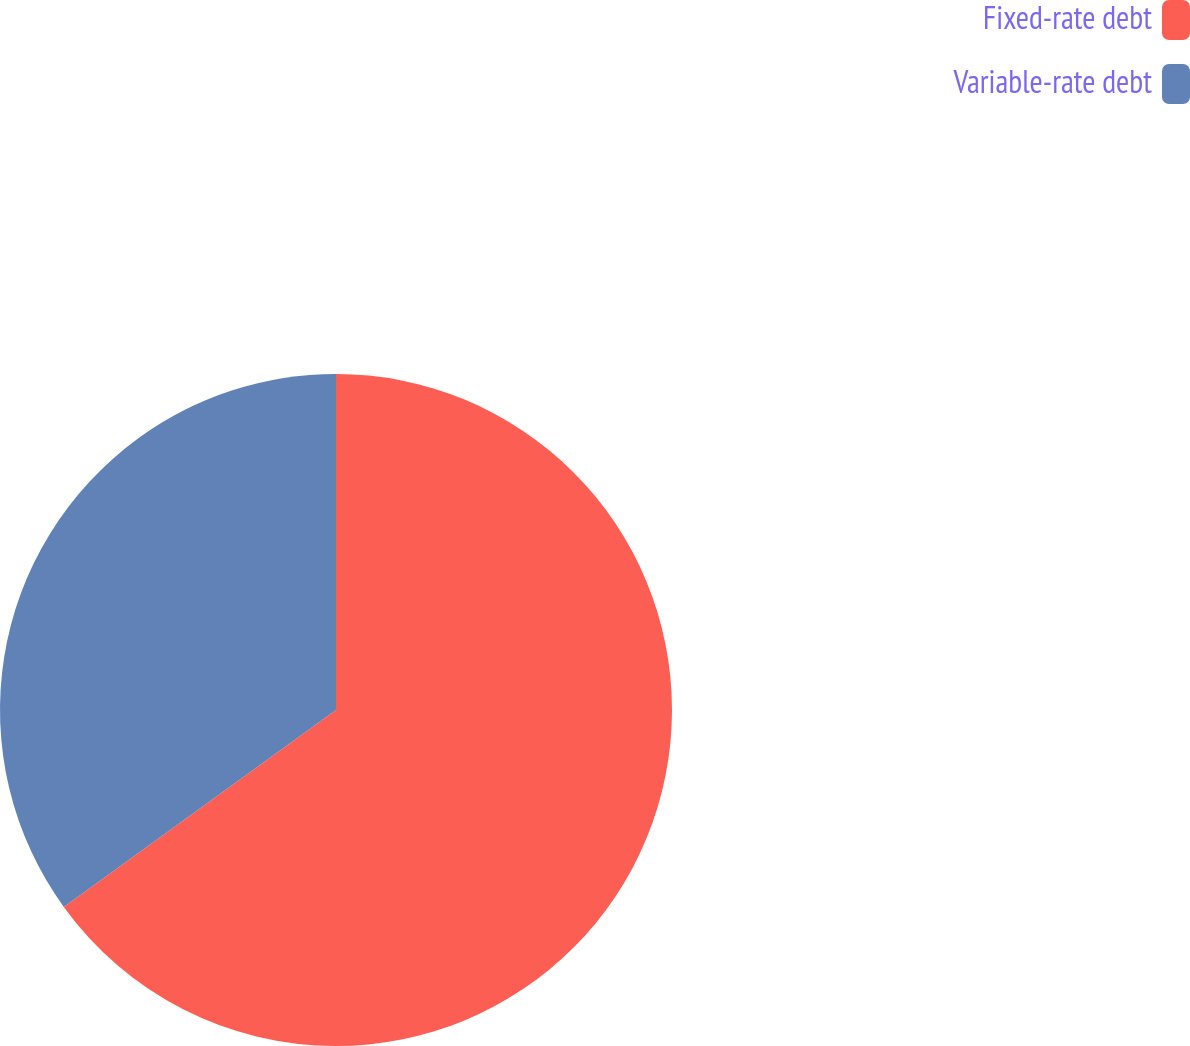Convert chart to OTSL. <chart><loc_0><loc_0><loc_500><loc_500><pie_chart><fcel>Fixed-rate debt<fcel>Variable-rate debt<nl><fcel>65.03%<fcel>34.97%<nl></chart> 